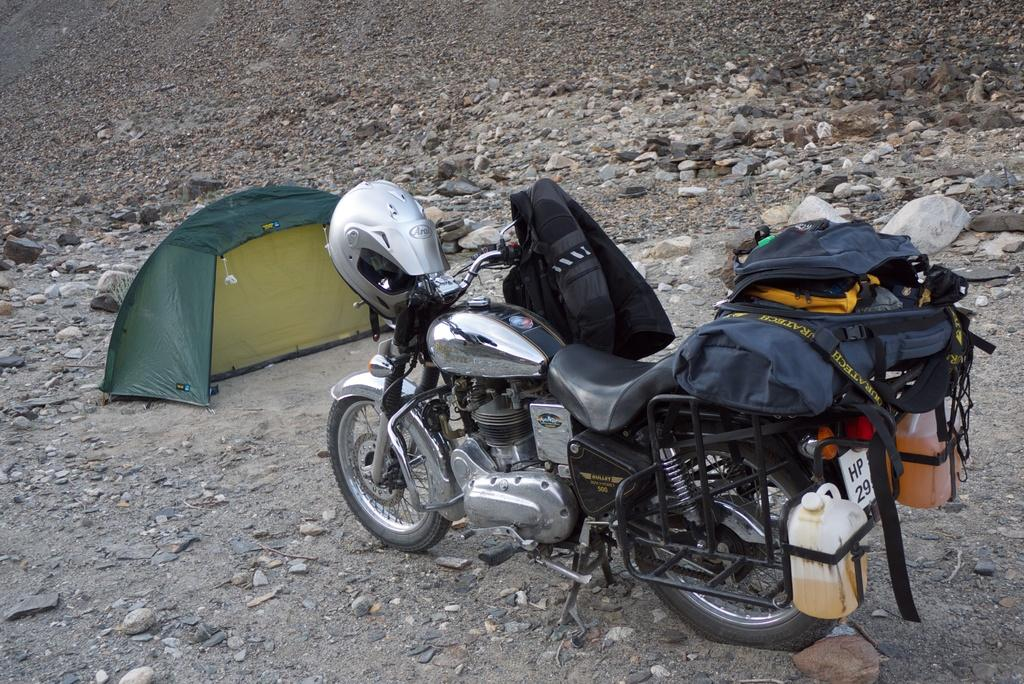What is the main object in the image? There is a bike in the image. What is attached to the bike? There are bags on the bike. What safety equipment is visible in the image? There is a helmet in the image. What can be seen on the left side of the image? There is a tent on the left side of the image. What type of drug is being used to hammer a sense into the bike in the image? There is no drug, hammer, or sense present in the image. The image only features a bike, bags, a helmet, and a tent. 